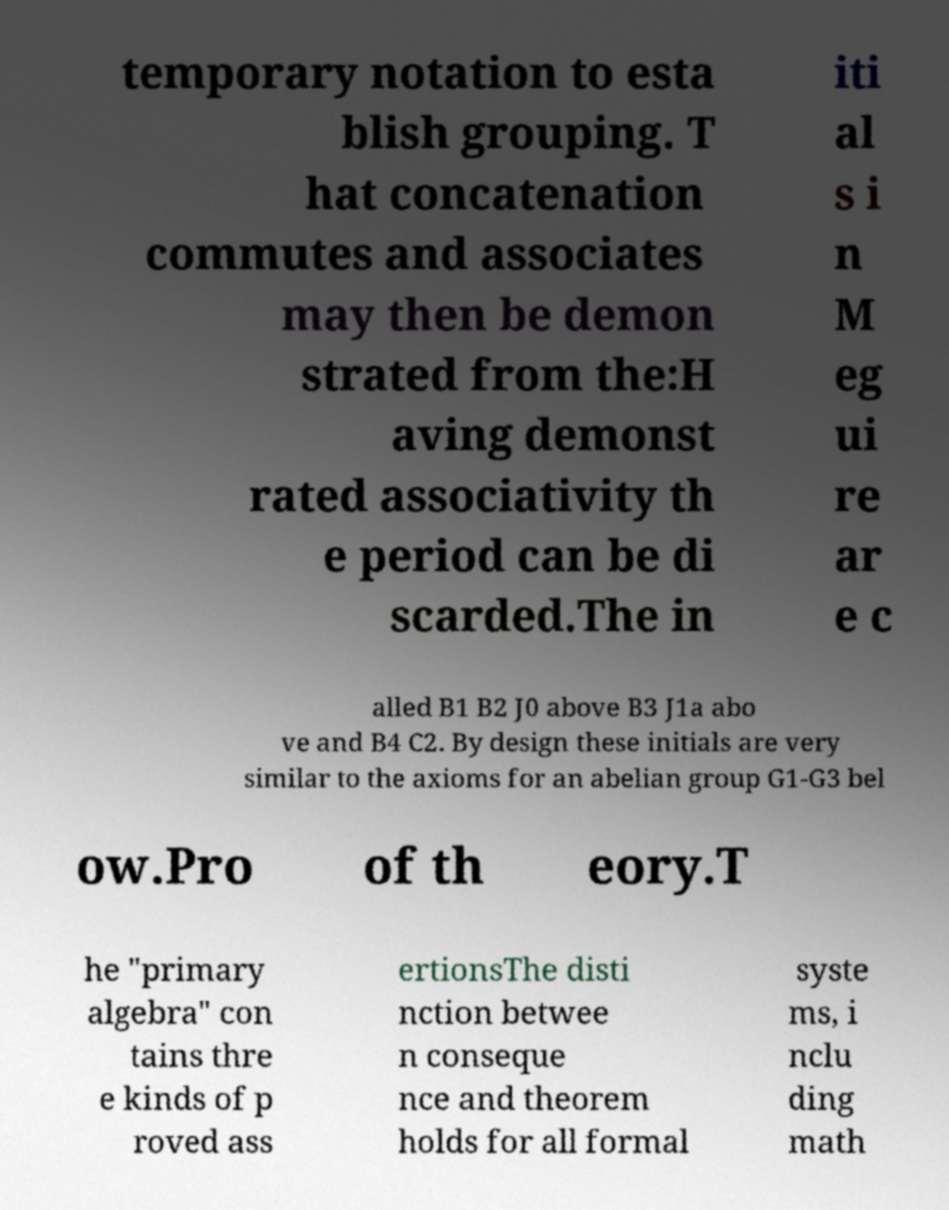I need the written content from this picture converted into text. Can you do that? temporary notation to esta blish grouping. T hat concatenation commutes and associates may then be demon strated from the:H aving demonst rated associativity th e period can be di scarded.The in iti al s i n M eg ui re ar e c alled B1 B2 J0 above B3 J1a abo ve and B4 C2. By design these initials are very similar to the axioms for an abelian group G1-G3 bel ow.Pro of th eory.T he "primary algebra" con tains thre e kinds of p roved ass ertionsThe disti nction betwee n conseque nce and theorem holds for all formal syste ms, i nclu ding math 